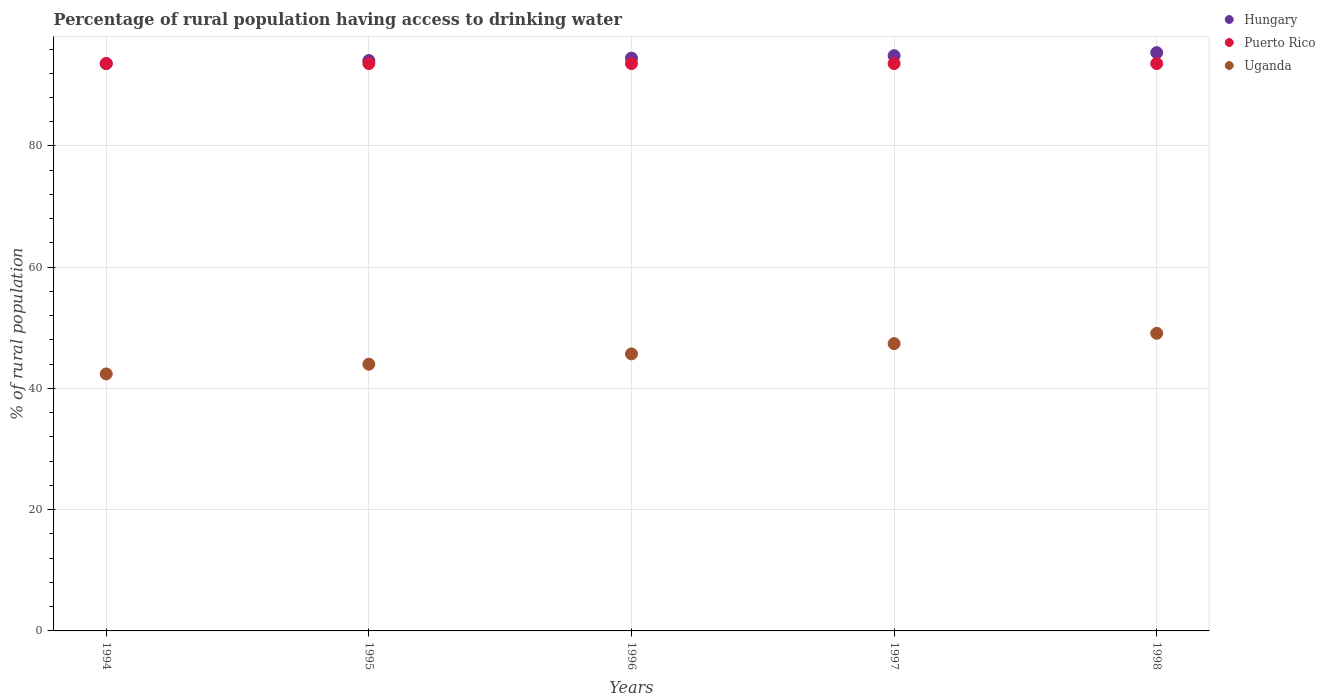Is the number of dotlines equal to the number of legend labels?
Your answer should be very brief. Yes. What is the percentage of rural population having access to drinking water in Puerto Rico in 1996?
Make the answer very short. 93.6. Across all years, what is the maximum percentage of rural population having access to drinking water in Puerto Rico?
Make the answer very short. 93.6. Across all years, what is the minimum percentage of rural population having access to drinking water in Uganda?
Provide a short and direct response. 42.4. In which year was the percentage of rural population having access to drinking water in Hungary maximum?
Your answer should be compact. 1998. In which year was the percentage of rural population having access to drinking water in Puerto Rico minimum?
Give a very brief answer. 1994. What is the total percentage of rural population having access to drinking water in Puerto Rico in the graph?
Offer a very short reply. 468. What is the difference between the percentage of rural population having access to drinking water in Hungary in 1996 and that in 1998?
Your answer should be very brief. -0.9. What is the difference between the percentage of rural population having access to drinking water in Uganda in 1994 and the percentage of rural population having access to drinking water in Puerto Rico in 1996?
Your response must be concise. -51.2. What is the average percentage of rural population having access to drinking water in Hungary per year?
Offer a terse response. 94.5. In the year 1997, what is the difference between the percentage of rural population having access to drinking water in Puerto Rico and percentage of rural population having access to drinking water in Uganda?
Ensure brevity in your answer.  46.2. In how many years, is the percentage of rural population having access to drinking water in Puerto Rico greater than 24 %?
Provide a succinct answer. 5. What is the ratio of the percentage of rural population having access to drinking water in Uganda in 1996 to that in 1997?
Offer a terse response. 0.96. What is the difference between the highest and the lowest percentage of rural population having access to drinking water in Uganda?
Ensure brevity in your answer.  6.7. In how many years, is the percentage of rural population having access to drinking water in Hungary greater than the average percentage of rural population having access to drinking water in Hungary taken over all years?
Offer a very short reply. 2. What is the difference between two consecutive major ticks on the Y-axis?
Keep it short and to the point. 20. Are the values on the major ticks of Y-axis written in scientific E-notation?
Provide a short and direct response. No. Does the graph contain any zero values?
Provide a succinct answer. No. Does the graph contain grids?
Keep it short and to the point. Yes. How many legend labels are there?
Ensure brevity in your answer.  3. How are the legend labels stacked?
Your answer should be compact. Vertical. What is the title of the graph?
Make the answer very short. Percentage of rural population having access to drinking water. Does "Lithuania" appear as one of the legend labels in the graph?
Your answer should be very brief. No. What is the label or title of the Y-axis?
Your answer should be compact. % of rural population. What is the % of rural population in Hungary in 1994?
Make the answer very short. 93.6. What is the % of rural population of Puerto Rico in 1994?
Keep it short and to the point. 93.6. What is the % of rural population in Uganda in 1994?
Give a very brief answer. 42.4. What is the % of rural population in Hungary in 1995?
Offer a terse response. 94.1. What is the % of rural population of Puerto Rico in 1995?
Offer a terse response. 93.6. What is the % of rural population in Uganda in 1995?
Offer a very short reply. 44. What is the % of rural population of Hungary in 1996?
Give a very brief answer. 94.5. What is the % of rural population of Puerto Rico in 1996?
Offer a terse response. 93.6. What is the % of rural population of Uganda in 1996?
Your answer should be very brief. 45.7. What is the % of rural population in Hungary in 1997?
Keep it short and to the point. 94.9. What is the % of rural population of Puerto Rico in 1997?
Offer a terse response. 93.6. What is the % of rural population in Uganda in 1997?
Give a very brief answer. 47.4. What is the % of rural population of Hungary in 1998?
Provide a succinct answer. 95.4. What is the % of rural population of Puerto Rico in 1998?
Provide a short and direct response. 93.6. What is the % of rural population of Uganda in 1998?
Provide a succinct answer. 49.1. Across all years, what is the maximum % of rural population of Hungary?
Your answer should be very brief. 95.4. Across all years, what is the maximum % of rural population in Puerto Rico?
Give a very brief answer. 93.6. Across all years, what is the maximum % of rural population in Uganda?
Make the answer very short. 49.1. Across all years, what is the minimum % of rural population in Hungary?
Keep it short and to the point. 93.6. Across all years, what is the minimum % of rural population of Puerto Rico?
Your response must be concise. 93.6. Across all years, what is the minimum % of rural population in Uganda?
Keep it short and to the point. 42.4. What is the total % of rural population of Hungary in the graph?
Provide a short and direct response. 472.5. What is the total % of rural population of Puerto Rico in the graph?
Make the answer very short. 468. What is the total % of rural population of Uganda in the graph?
Make the answer very short. 228.6. What is the difference between the % of rural population in Puerto Rico in 1994 and that in 1996?
Your answer should be compact. 0. What is the difference between the % of rural population in Uganda in 1994 and that in 1996?
Keep it short and to the point. -3.3. What is the difference between the % of rural population in Hungary in 1994 and that in 1997?
Provide a succinct answer. -1.3. What is the difference between the % of rural population in Puerto Rico in 1994 and that in 1997?
Give a very brief answer. 0. What is the difference between the % of rural population of Hungary in 1994 and that in 1998?
Your response must be concise. -1.8. What is the difference between the % of rural population in Puerto Rico in 1994 and that in 1998?
Your response must be concise. 0. What is the difference between the % of rural population in Hungary in 1995 and that in 1996?
Make the answer very short. -0.4. What is the difference between the % of rural population in Uganda in 1995 and that in 1996?
Provide a succinct answer. -1.7. What is the difference between the % of rural population in Puerto Rico in 1995 and that in 1997?
Provide a succinct answer. 0. What is the difference between the % of rural population in Uganda in 1995 and that in 1997?
Give a very brief answer. -3.4. What is the difference between the % of rural population of Puerto Rico in 1995 and that in 1998?
Provide a succinct answer. 0. What is the difference between the % of rural population in Uganda in 1995 and that in 1998?
Give a very brief answer. -5.1. What is the difference between the % of rural population of Hungary in 1996 and that in 1997?
Your answer should be very brief. -0.4. What is the difference between the % of rural population of Uganda in 1996 and that in 1998?
Ensure brevity in your answer.  -3.4. What is the difference between the % of rural population of Uganda in 1997 and that in 1998?
Provide a short and direct response. -1.7. What is the difference between the % of rural population in Hungary in 1994 and the % of rural population in Puerto Rico in 1995?
Give a very brief answer. 0. What is the difference between the % of rural population of Hungary in 1994 and the % of rural population of Uganda in 1995?
Keep it short and to the point. 49.6. What is the difference between the % of rural population of Puerto Rico in 1994 and the % of rural population of Uganda in 1995?
Provide a succinct answer. 49.6. What is the difference between the % of rural population in Hungary in 1994 and the % of rural population in Puerto Rico in 1996?
Offer a very short reply. 0. What is the difference between the % of rural population in Hungary in 1994 and the % of rural population in Uganda in 1996?
Ensure brevity in your answer.  47.9. What is the difference between the % of rural population in Puerto Rico in 1994 and the % of rural population in Uganda in 1996?
Your response must be concise. 47.9. What is the difference between the % of rural population in Hungary in 1994 and the % of rural population in Puerto Rico in 1997?
Make the answer very short. 0. What is the difference between the % of rural population in Hungary in 1994 and the % of rural population in Uganda in 1997?
Offer a terse response. 46.2. What is the difference between the % of rural population of Puerto Rico in 1994 and the % of rural population of Uganda in 1997?
Offer a terse response. 46.2. What is the difference between the % of rural population of Hungary in 1994 and the % of rural population of Uganda in 1998?
Your response must be concise. 44.5. What is the difference between the % of rural population in Puerto Rico in 1994 and the % of rural population in Uganda in 1998?
Give a very brief answer. 44.5. What is the difference between the % of rural population of Hungary in 1995 and the % of rural population of Uganda in 1996?
Give a very brief answer. 48.4. What is the difference between the % of rural population of Puerto Rico in 1995 and the % of rural population of Uganda in 1996?
Make the answer very short. 47.9. What is the difference between the % of rural population of Hungary in 1995 and the % of rural population of Puerto Rico in 1997?
Provide a short and direct response. 0.5. What is the difference between the % of rural population in Hungary in 1995 and the % of rural population in Uganda in 1997?
Offer a terse response. 46.7. What is the difference between the % of rural population in Puerto Rico in 1995 and the % of rural population in Uganda in 1997?
Your response must be concise. 46.2. What is the difference between the % of rural population of Hungary in 1995 and the % of rural population of Puerto Rico in 1998?
Keep it short and to the point. 0.5. What is the difference between the % of rural population of Puerto Rico in 1995 and the % of rural population of Uganda in 1998?
Offer a very short reply. 44.5. What is the difference between the % of rural population in Hungary in 1996 and the % of rural population in Puerto Rico in 1997?
Offer a terse response. 0.9. What is the difference between the % of rural population of Hungary in 1996 and the % of rural population of Uganda in 1997?
Keep it short and to the point. 47.1. What is the difference between the % of rural population in Puerto Rico in 1996 and the % of rural population in Uganda in 1997?
Provide a short and direct response. 46.2. What is the difference between the % of rural population in Hungary in 1996 and the % of rural population in Uganda in 1998?
Provide a succinct answer. 45.4. What is the difference between the % of rural population in Puerto Rico in 1996 and the % of rural population in Uganda in 1998?
Ensure brevity in your answer.  44.5. What is the difference between the % of rural population of Hungary in 1997 and the % of rural population of Puerto Rico in 1998?
Your answer should be compact. 1.3. What is the difference between the % of rural population of Hungary in 1997 and the % of rural population of Uganda in 1998?
Provide a succinct answer. 45.8. What is the difference between the % of rural population of Puerto Rico in 1997 and the % of rural population of Uganda in 1998?
Offer a terse response. 44.5. What is the average % of rural population of Hungary per year?
Provide a short and direct response. 94.5. What is the average % of rural population of Puerto Rico per year?
Offer a terse response. 93.6. What is the average % of rural population of Uganda per year?
Provide a succinct answer. 45.72. In the year 1994, what is the difference between the % of rural population of Hungary and % of rural population of Uganda?
Provide a succinct answer. 51.2. In the year 1994, what is the difference between the % of rural population of Puerto Rico and % of rural population of Uganda?
Keep it short and to the point. 51.2. In the year 1995, what is the difference between the % of rural population of Hungary and % of rural population of Uganda?
Your answer should be compact. 50.1. In the year 1995, what is the difference between the % of rural population of Puerto Rico and % of rural population of Uganda?
Your answer should be compact. 49.6. In the year 1996, what is the difference between the % of rural population in Hungary and % of rural population in Uganda?
Keep it short and to the point. 48.8. In the year 1996, what is the difference between the % of rural population in Puerto Rico and % of rural population in Uganda?
Provide a short and direct response. 47.9. In the year 1997, what is the difference between the % of rural population in Hungary and % of rural population in Uganda?
Give a very brief answer. 47.5. In the year 1997, what is the difference between the % of rural population in Puerto Rico and % of rural population in Uganda?
Give a very brief answer. 46.2. In the year 1998, what is the difference between the % of rural population in Hungary and % of rural population in Uganda?
Make the answer very short. 46.3. In the year 1998, what is the difference between the % of rural population of Puerto Rico and % of rural population of Uganda?
Provide a succinct answer. 44.5. What is the ratio of the % of rural population of Hungary in 1994 to that in 1995?
Make the answer very short. 0.99. What is the ratio of the % of rural population of Puerto Rico in 1994 to that in 1995?
Provide a succinct answer. 1. What is the ratio of the % of rural population in Uganda in 1994 to that in 1995?
Your response must be concise. 0.96. What is the ratio of the % of rural population in Uganda in 1994 to that in 1996?
Offer a terse response. 0.93. What is the ratio of the % of rural population in Hungary in 1994 to that in 1997?
Provide a short and direct response. 0.99. What is the ratio of the % of rural population of Uganda in 1994 to that in 1997?
Your answer should be compact. 0.89. What is the ratio of the % of rural population in Hungary in 1994 to that in 1998?
Give a very brief answer. 0.98. What is the ratio of the % of rural population in Uganda in 1994 to that in 1998?
Provide a short and direct response. 0.86. What is the ratio of the % of rural population in Hungary in 1995 to that in 1996?
Keep it short and to the point. 1. What is the ratio of the % of rural population in Puerto Rico in 1995 to that in 1996?
Ensure brevity in your answer.  1. What is the ratio of the % of rural population of Uganda in 1995 to that in 1996?
Give a very brief answer. 0.96. What is the ratio of the % of rural population in Uganda in 1995 to that in 1997?
Ensure brevity in your answer.  0.93. What is the ratio of the % of rural population of Hungary in 1995 to that in 1998?
Ensure brevity in your answer.  0.99. What is the ratio of the % of rural population of Uganda in 1995 to that in 1998?
Make the answer very short. 0.9. What is the ratio of the % of rural population of Uganda in 1996 to that in 1997?
Offer a very short reply. 0.96. What is the ratio of the % of rural population in Hungary in 1996 to that in 1998?
Provide a succinct answer. 0.99. What is the ratio of the % of rural population of Uganda in 1996 to that in 1998?
Offer a terse response. 0.93. What is the ratio of the % of rural population in Hungary in 1997 to that in 1998?
Offer a terse response. 0.99. What is the ratio of the % of rural population in Puerto Rico in 1997 to that in 1998?
Your response must be concise. 1. What is the ratio of the % of rural population in Uganda in 1997 to that in 1998?
Ensure brevity in your answer.  0.97. What is the difference between the highest and the second highest % of rural population in Puerto Rico?
Provide a short and direct response. 0. What is the difference between the highest and the second highest % of rural population in Uganda?
Offer a terse response. 1.7. What is the difference between the highest and the lowest % of rural population of Hungary?
Provide a succinct answer. 1.8. What is the difference between the highest and the lowest % of rural population of Uganda?
Give a very brief answer. 6.7. 